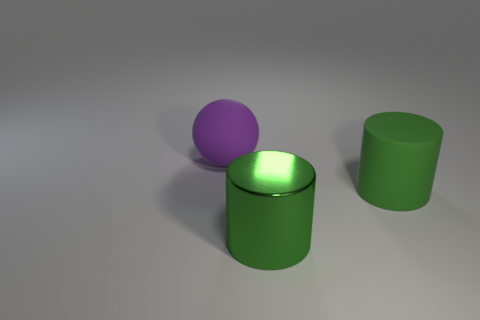How many objects are matte objects in front of the purple matte thing or rubber things that are in front of the large purple sphere?
Offer a terse response. 1. What number of things are big matte things or big cylinders that are to the left of the large green rubber cylinder?
Give a very brief answer. 3. What size is the rubber object on the right side of the green cylinder in front of the matte thing in front of the big ball?
Give a very brief answer. Large. There is a cylinder that is the same size as the green metal object; what is it made of?
Give a very brief answer. Rubber. Are there any purple things that have the same size as the green metallic object?
Your answer should be compact. Yes. There is a matte thing on the right side of the purple thing; does it have the same size as the big green shiny cylinder?
Give a very brief answer. Yes. There is a thing that is both left of the big green rubber cylinder and behind the large green metallic cylinder; what shape is it?
Ensure brevity in your answer.  Sphere. Are there more big cylinders that are right of the big metallic thing than cyan cubes?
Your answer should be very brief. Yes. What size is the other object that is the same material as the large purple thing?
Keep it short and to the point. Large. What number of big cylinders have the same color as the shiny object?
Provide a succinct answer. 1. 